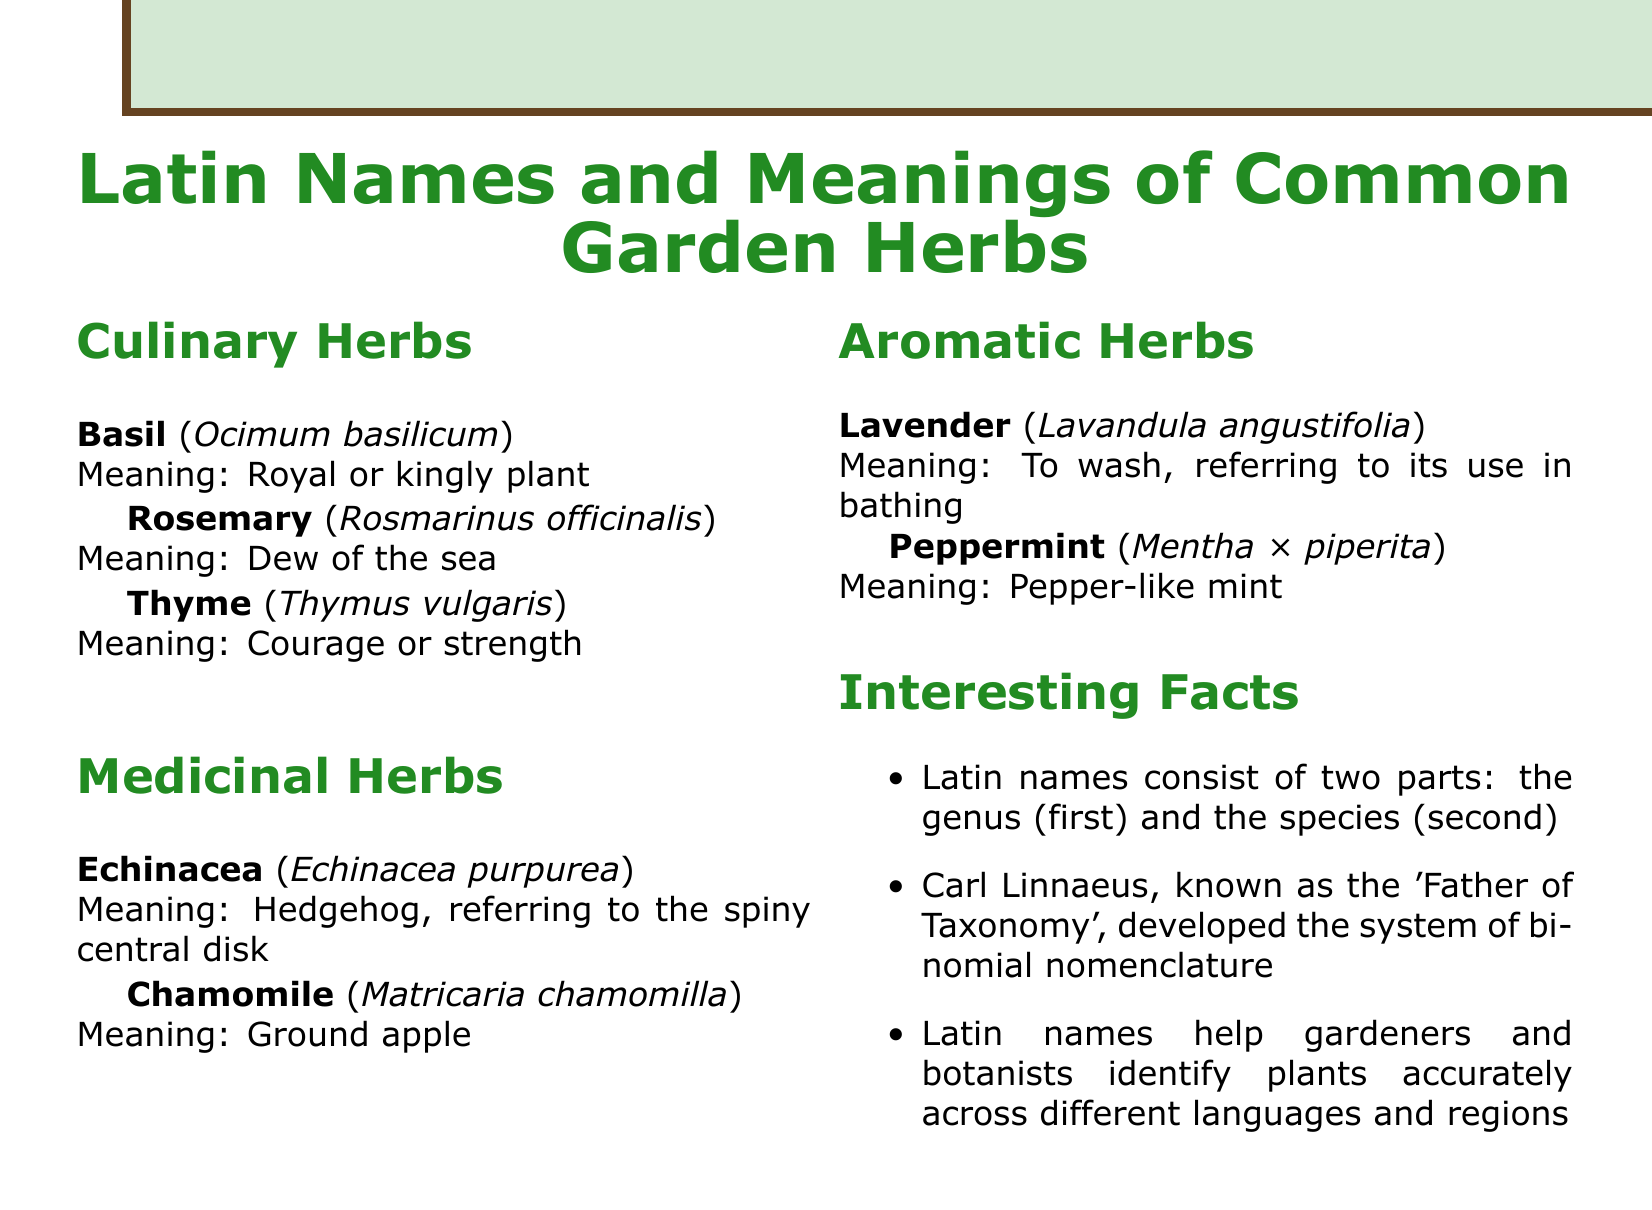What is the Latin name for Basil? The Latin name for Basil is listed under the Culinary Herbs section.
Answer: Ocimum basilicum What does the Latin name "Rosmarinus officinalis" mean? The meaning of the Latin name "Rosmarinus officinalis" is provided in the document.
Answer: Dew of the sea Which herb is referred to as the "Hedgehog"? The document mentions that Echinacea is referred to as the "Hedgehog" because of its appearance.
Answer: Echinacea How many sections are there in the document? The document contains four main sections detailing different categories of herbs.
Answer: Four What is the significance of Carl Linnaeus in plant taxonomy? The document explains that Carl Linnaeus developed the system of binomial nomenclature, making him significant in plant taxonomy.
Answer: Father of Taxonomy What does "Thymus vulgaris" mean? The document states that the meaning of "Thymus vulgaris" relates to courage or strength.
Answer: Courage or strength What two parts make up a Latin name? The document specifies that Latin names consist of two parts.
Answer: Genus and species 